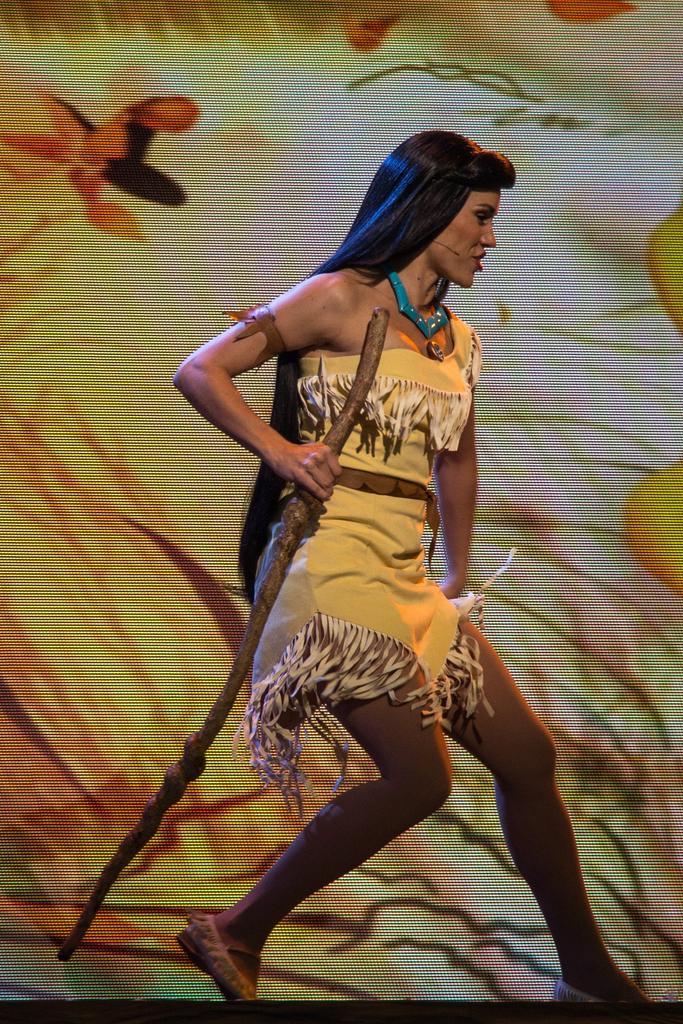Describe this image in one or two sentences. In this image we can see a woman holding a stick. And in the background, we can see the poster/curtain. 